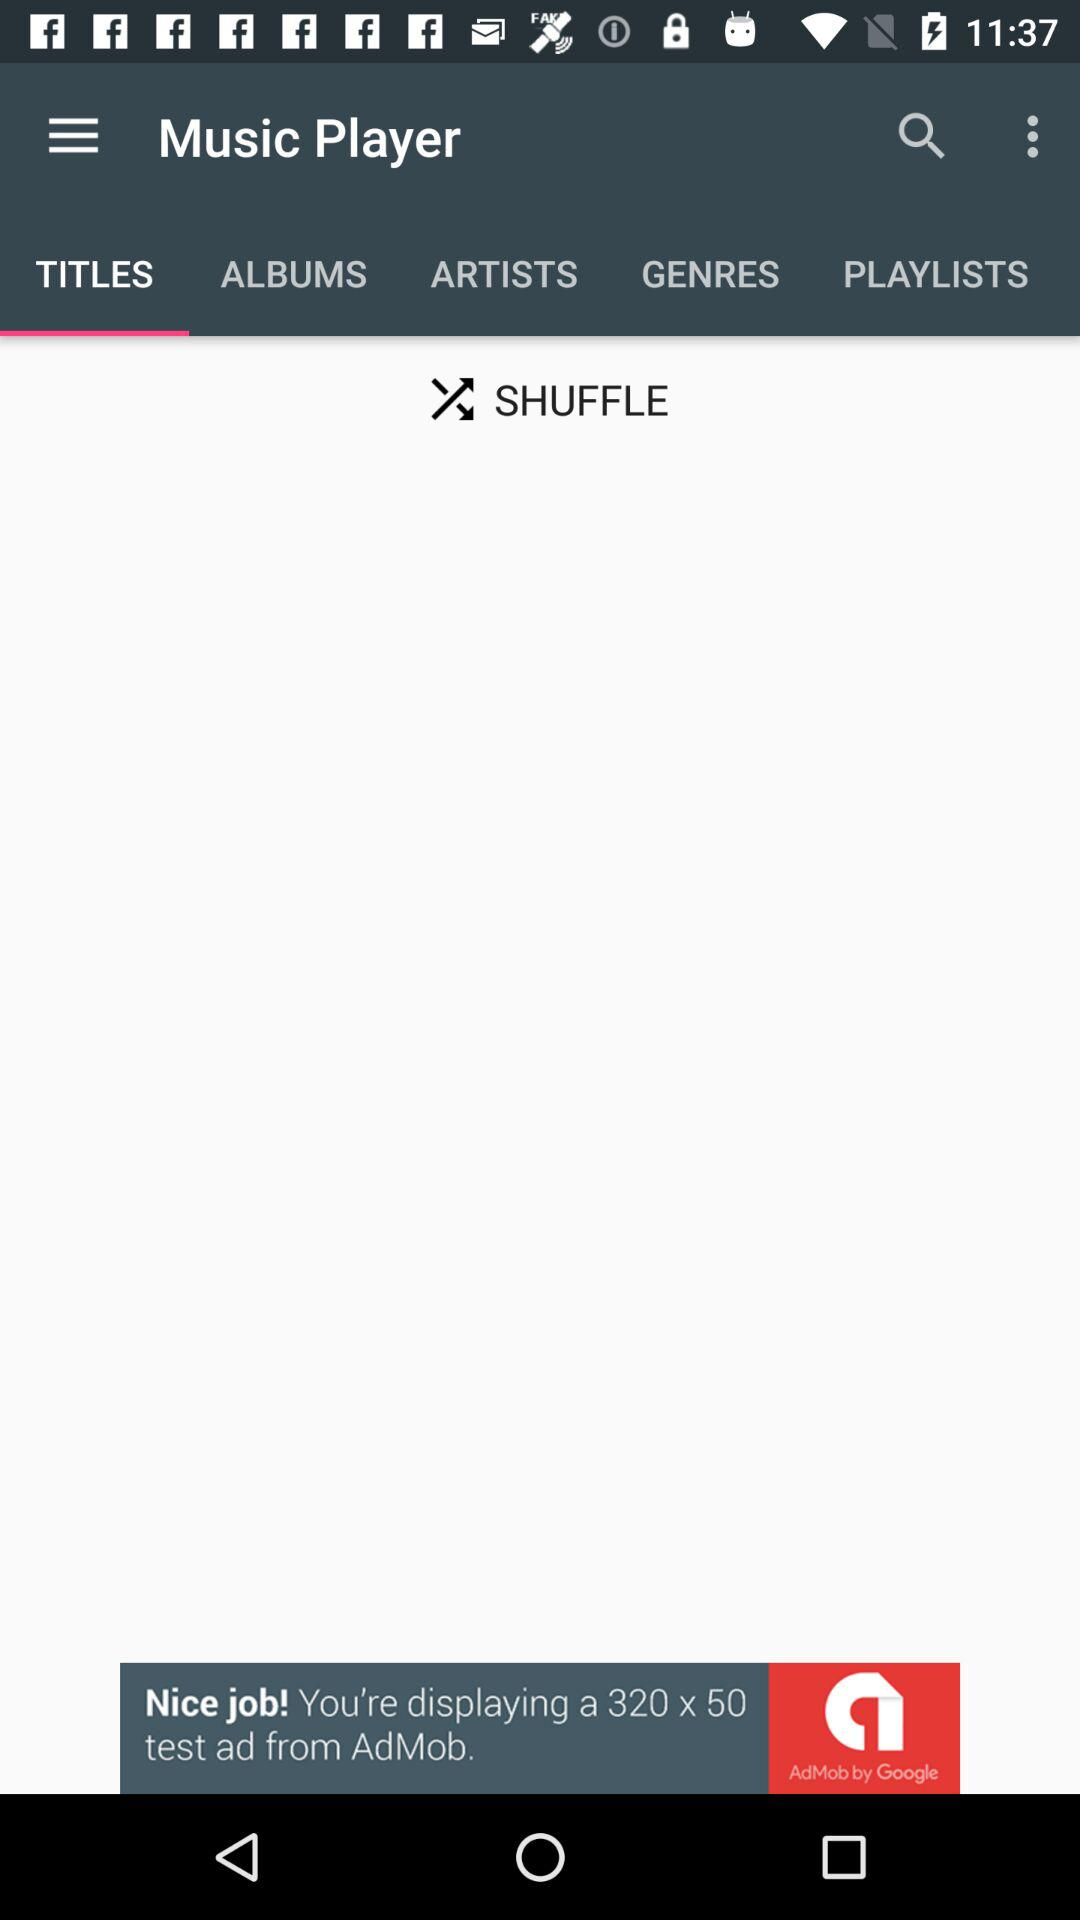Which tab am I on? You are on the "TITLES" tab. 